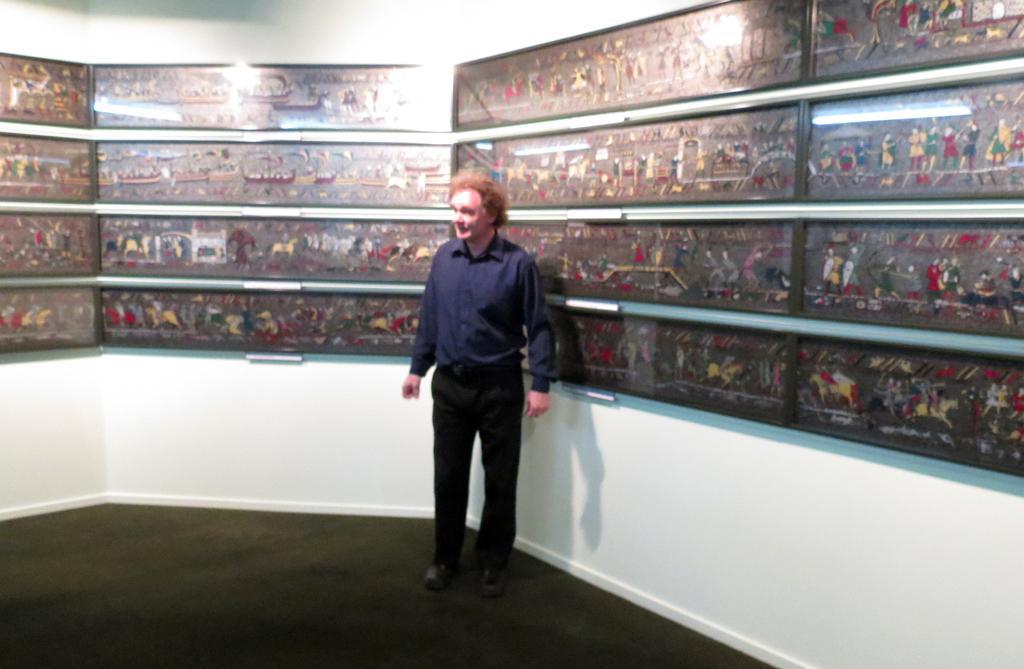Describe this image in one or two sentences. This image consists of a person who is wearing navy blue shirt and black pant. He is wearing shoes. He is in a room. There are so many photo frames all over the wall. 